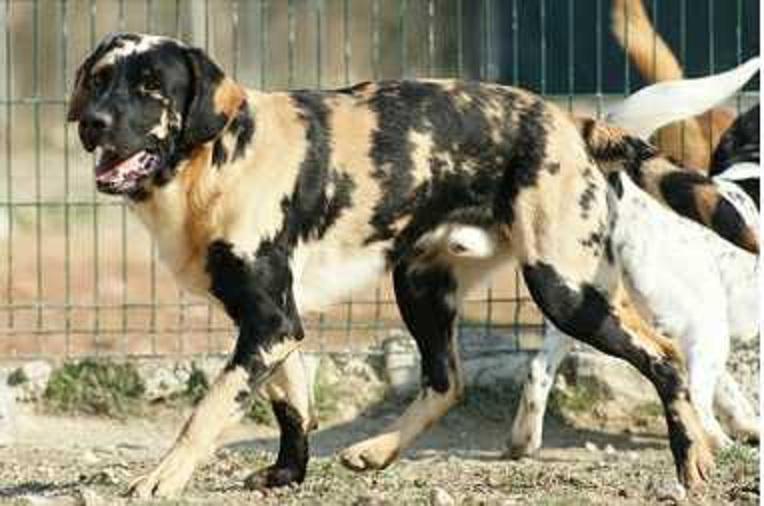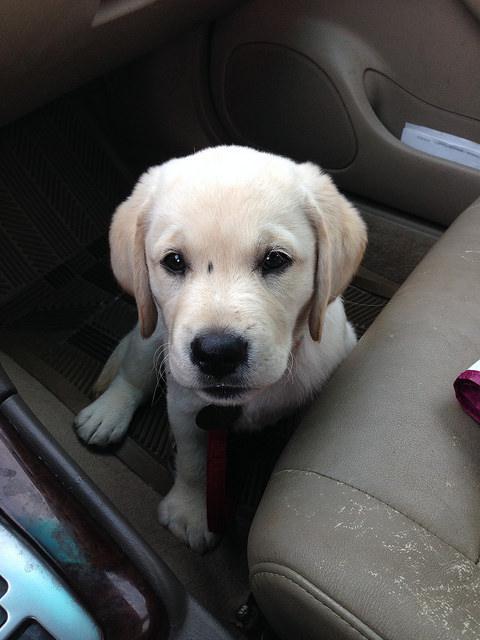The first image is the image on the left, the second image is the image on the right. Examine the images to the left and right. Is the description "There are more animals in the image on the left." accurate? Answer yes or no. Yes. The first image is the image on the left, the second image is the image on the right. Analyze the images presented: Is the assertion "A dog has orangish-blond fur and a dark uneven stripe that runs from above one eye to its nose." valid? Answer yes or no. No. 